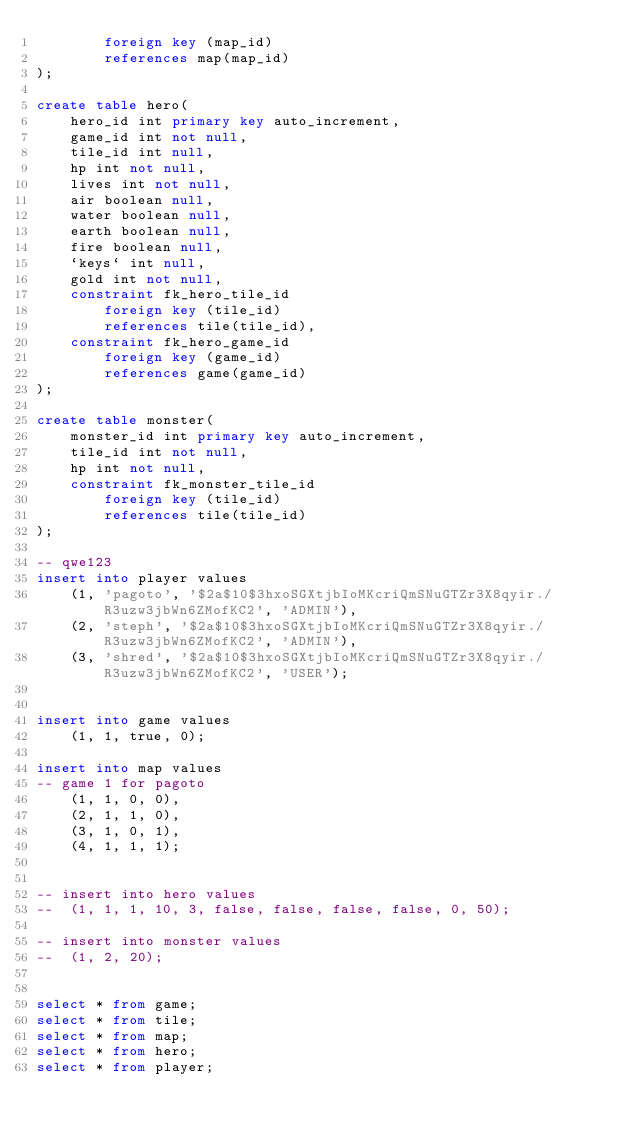Convert code to text. <code><loc_0><loc_0><loc_500><loc_500><_SQL_>		foreign key (map_id)
        references map(map_id)
);

create table hero(
	hero_id int primary key auto_increment,
    game_id int not null,
    tile_id int null,
    hp int not null,
    lives int not null,
    air boolean null,
    water boolean null,
    earth boolean null,
    fire boolean null,
    `keys` int null,
    gold int not null,
    constraint fk_hero_tile_id
		foreign key (tile_id)
        references tile(tile_id),
	constraint fk_hero_game_id
		foreign key (game_id)
		references game(game_id)		
);

create table monster(
	monster_id int primary key auto_increment,
    tile_id int not null,
    hp int not null,
    constraint fk_monster_tile_id
		foreign key (tile_id)
        references tile(tile_id)
);
    
-- qwe123
insert into player values
	(1, 'pagoto', '$2a$10$3hxoSGXtjbIoMKcriQmSNuGTZr3X8qyir./R3uzw3jbWn6ZMofKC2', 'ADMIN'), 
    (2, 'steph', '$2a$10$3hxoSGXtjbIoMKcriQmSNuGTZr3X8qyir./R3uzw3jbWn6ZMofKC2', 'ADMIN'),
    (3, 'shred', '$2a$10$3hxoSGXtjbIoMKcriQmSNuGTZr3X8qyir./R3uzw3jbWn6ZMofKC2', 'USER');

    
insert into game values
	(1, 1, true, 0);
    
insert into map values
-- game 1 for pagoto
	(1, 1, 0, 0), 
    (2, 1, 1, 0),
    (3, 1, 0, 1),
    (4, 1, 1, 1);


-- insert into hero values
-- 	(1, 1, 1, 10, 3, false, false, false, false, 0, 50);
    
-- insert into monster values
-- 	(1, 2, 20);
    

select * from game;
select * from tile;
select * from map;
select * from hero;
select * from player;</code> 